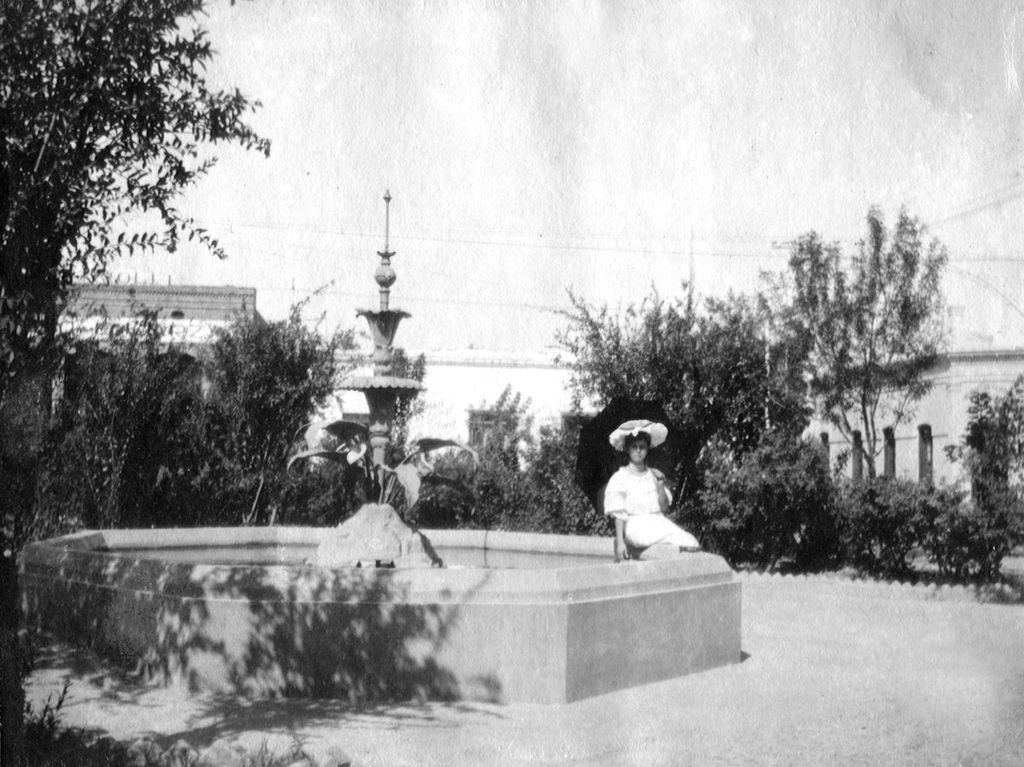How would you summarize this image in a sentence or two? This is a black and white image. In the mage there is a fountain. On the fountain wall there is a lady sitting. Behind her there are many trees. Behind the trees there are few buildings. 